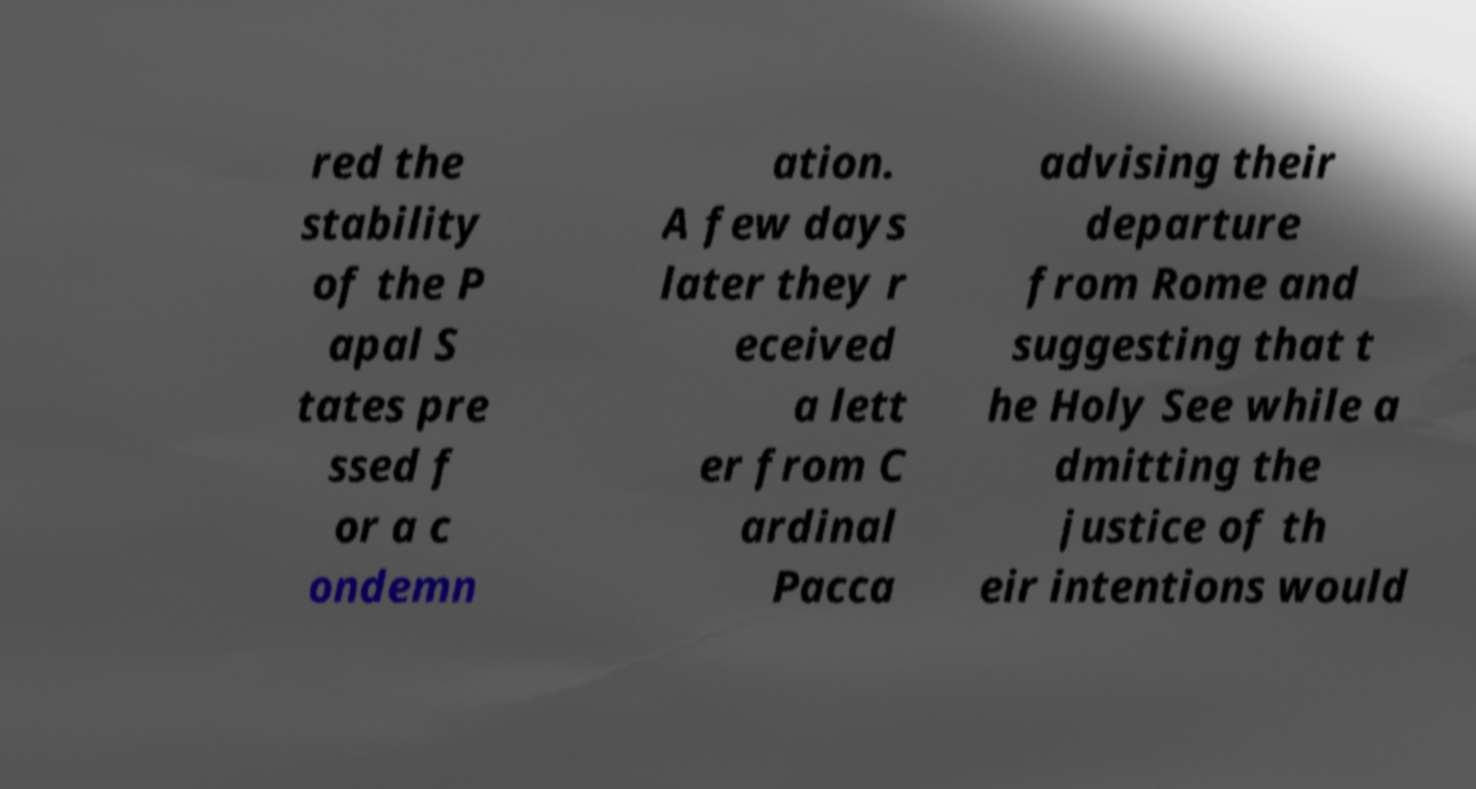There's text embedded in this image that I need extracted. Can you transcribe it verbatim? red the stability of the P apal S tates pre ssed f or a c ondemn ation. A few days later they r eceived a lett er from C ardinal Pacca advising their departure from Rome and suggesting that t he Holy See while a dmitting the justice of th eir intentions would 